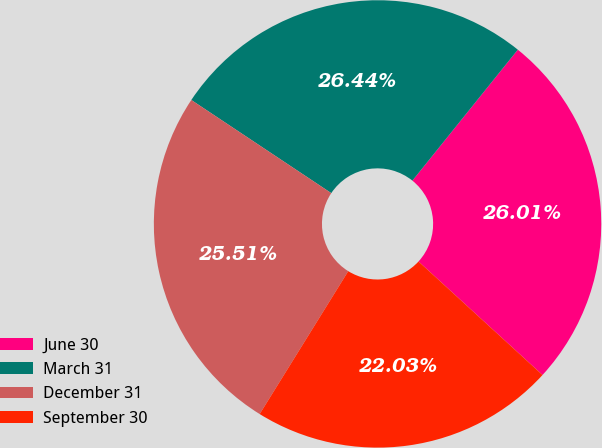<chart> <loc_0><loc_0><loc_500><loc_500><pie_chart><fcel>June 30<fcel>March 31<fcel>December 31<fcel>September 30<nl><fcel>26.01%<fcel>26.44%<fcel>25.51%<fcel>22.03%<nl></chart> 